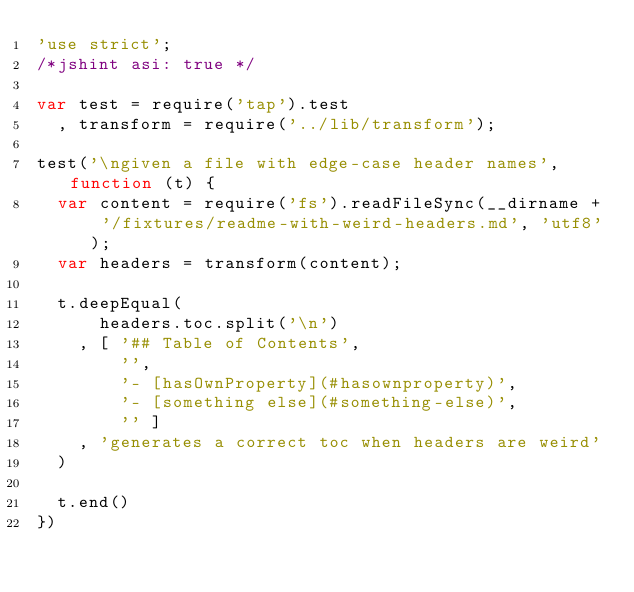<code> <loc_0><loc_0><loc_500><loc_500><_JavaScript_>'use strict';
/*jshint asi: true */

var test = require('tap').test
  , transform = require('../lib/transform');

test('\ngiven a file with edge-case header names', function (t) {
  var content = require('fs').readFileSync(__dirname + '/fixtures/readme-with-weird-headers.md', 'utf8');
  var headers = transform(content);

  t.deepEqual(
      headers.toc.split('\n')
    , [ '## Table of Contents',
        '',
        '- [hasOwnProperty](#hasownproperty)',
        '- [something else](#something-else)',
        '' ]
    , 'generates a correct toc when headers are weird'
  )

  t.end()
})
</code> 